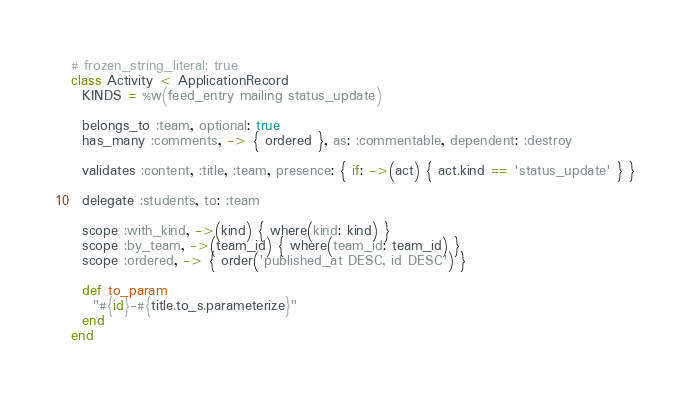Convert code to text. <code><loc_0><loc_0><loc_500><loc_500><_Ruby_># frozen_string_literal: true
class Activity < ApplicationRecord
  KINDS = %w(feed_entry mailing status_update)

  belongs_to :team, optional: true
  has_many :comments, -> { ordered }, as: :commentable, dependent: :destroy

  validates :content, :title, :team, presence: { if: ->(act) { act.kind == 'status_update' } }

  delegate :students, to: :team

  scope :with_kind, ->(kind) { where(kind: kind) }
  scope :by_team, ->(team_id) { where(team_id: team_id) }
  scope :ordered, -> { order('published_at DESC, id DESC') }

  def to_param
    "#{id}-#{title.to_s.parameterize}"
  end
end
</code> 